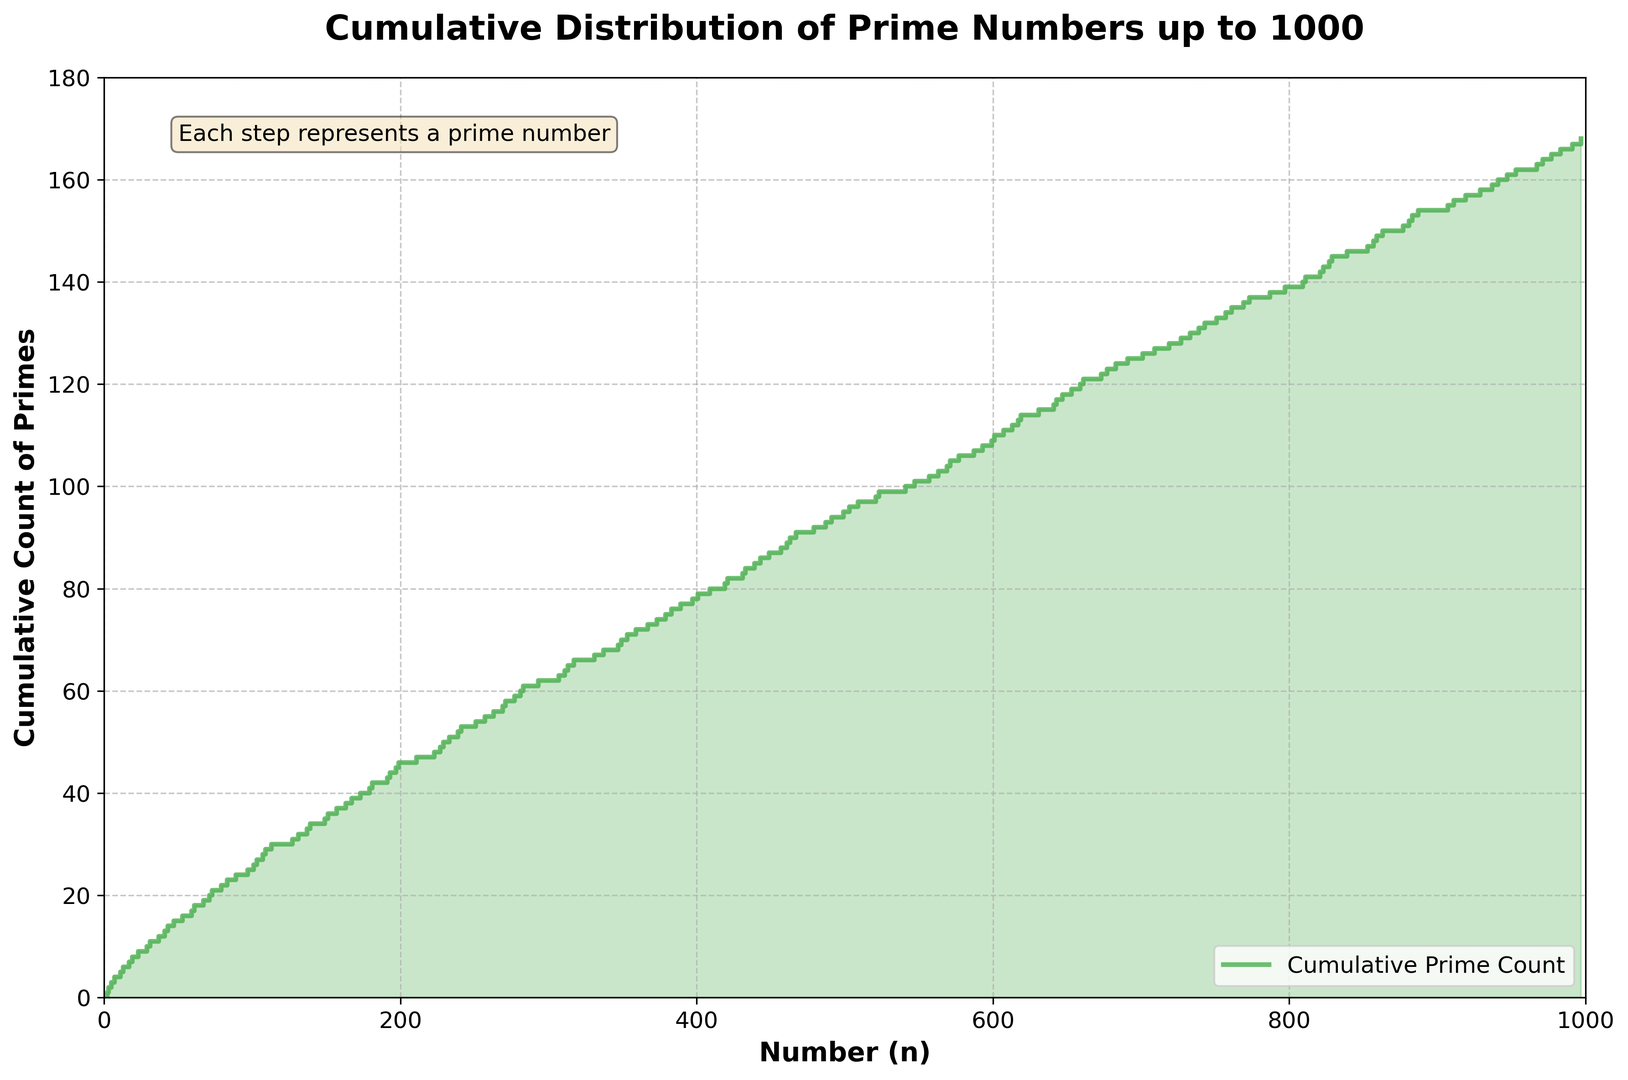What is the highest value on the cumulative count of primes axis? The highest value on the cumulative count of primes axis can be found by looking at the topmost horizontal line on the y-axis.
Answer: 168 At which number does the first step increase occur in the plot? The first step increase occurs at the first prime number. Look for the first non-zero value on the x-axis.
Answer: 2 By how much does the cumulative count increase between the number 11 and 19? To find the increase, identify the y-values at 11 and 19 and then subtract the earlier count from the latter. At 11, the count is 5, and at 19, the count is 8. So, 8 - 5 = 3.
Answer: 3 Which number has the 25th prime number? Find the y-value of 25 on the cumulative count axis and then locate the corresponding number on the x-axis.
Answer: 97 Is there an interval where no prime numbers appear between 1 and 1000 in the plot, and if so, what is the largest interval? Look for the longest horizontal line segment (where the y-value does not change) on the plot. Identify the start and end of this segment. The largest interval without primes appears between 887 and 907.
Answer: 20 How many primes are there up to the number 500 in the plot? Find the x-value of 500 on the plot and identify the corresponding y-value, which represents the cumulative count of primes up to 500.
Answer: 95 Does the plot have any visible trend or pattern in the distribution of prime numbers? Observe the overall direction and shape of the staircase plot. The plot shows a generally increasing trend but with larger gaps as the numbers increase.
Answer: Increasing trend with larger gaps as numbers increase By how much does the count increase between the number 251 and 401? Identify the y-values at 251 and 401 and compute the difference. At 251, count is 54, and at 401, count is 79, so 79 - 54 = 25.
Answer: 25 What color is used for the steps in the plot? Look at the color of the line representing the cumulative prime count.
Answer: Green Compare the cumulative count of primes at 197 and 307. Which one is greater, and by how much? Determine the y-values at 197 and 307. At 197, it is 45, and at 307, it is 63. Calculate the difference: 63 - 45 = 18.
Answer: 307 is greater by 18 